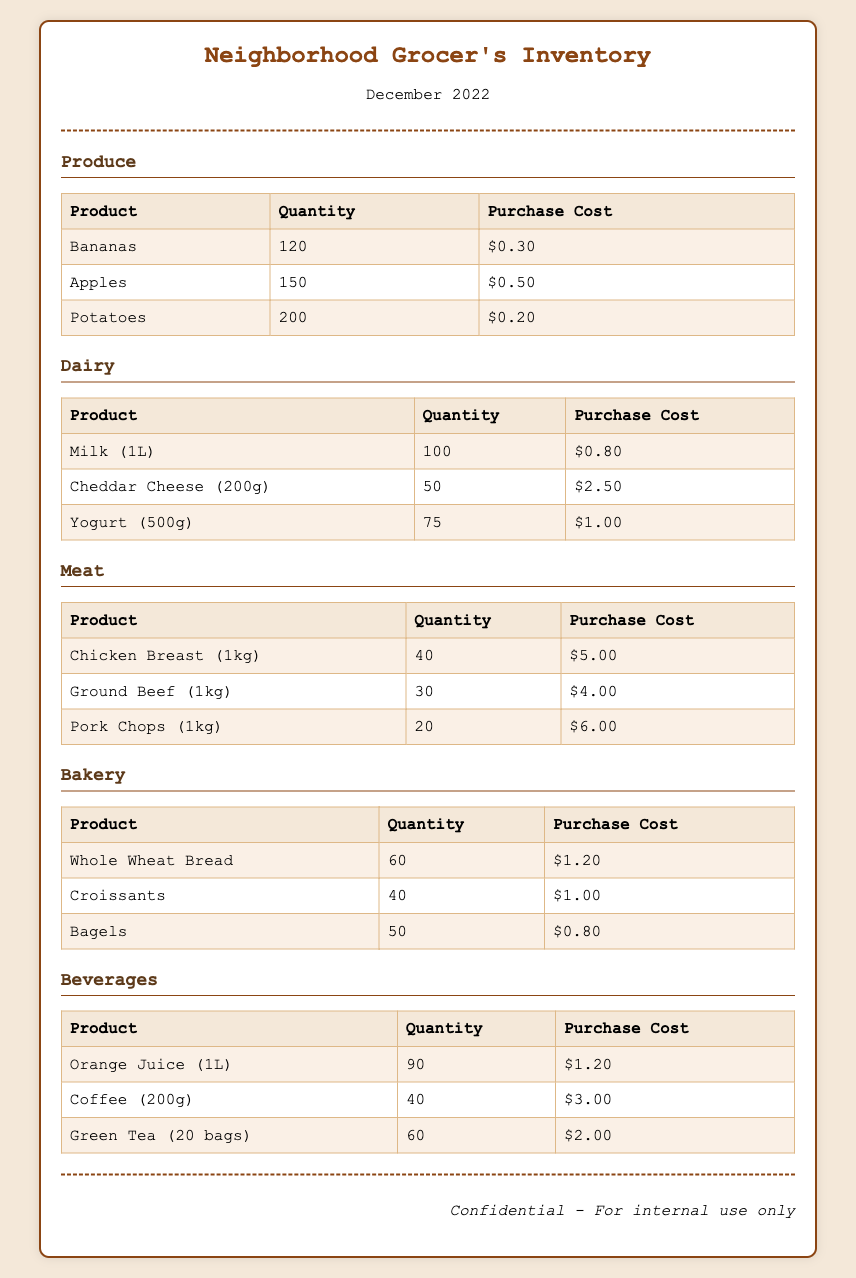what is the total quantity of Apples? The total quantity of Apples listed in the document is 150.
Answer: 150 how much does a pound of Chicken Breast cost? The purchase cost listed for Chicken Breast is $5.00 per kilogram, but there's no pound cost given.
Answer: $5.00 which product has the highest purchase cost in Dairy? The product with the highest purchase cost in the Dairy section is Cheddar Cheese at $2.50.
Answer: Cheddar Cheese how many Croissants are in inventory? The inventory shows that there are 40 Croissants.
Answer: 40 what is the total quantity of Potatoes? The document states the total quantity of Potatoes is 200.
Answer: 200 how many products are listed under Bakery? There are three products listed under the Bakery section: Whole Wheat Bread, Croissants, and Bagels.
Answer: 3 which beverage has the lowest purchase cost? The beverage with the lowest purchase cost is Green Tea at $2.00.
Answer: Green Tea how many items are listed in the Meat section? There are three items listed in the Meat section: Chicken Breast, Ground Beef, and Pork Chops.
Answer: 3 what is the total quantity of Beverages? The total quantity of Beverages listed in the document is 90 (Orange Juice) + 40 (Coffee) + 60 (Green Tea) = 190.
Answer: 190 